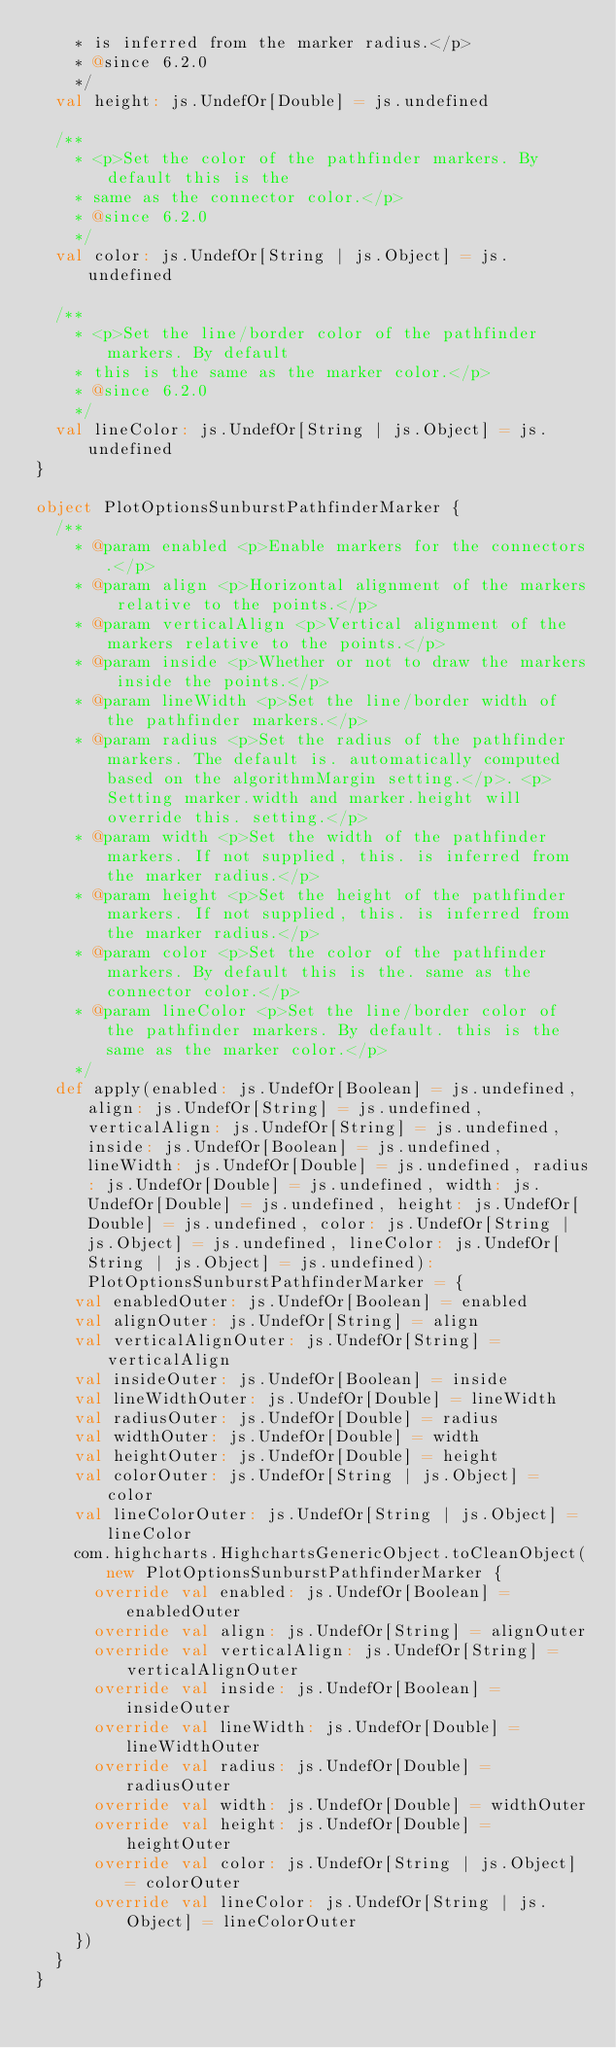Convert code to text. <code><loc_0><loc_0><loc_500><loc_500><_Scala_>    * is inferred from the marker radius.</p>
    * @since 6.2.0
    */
  val height: js.UndefOr[Double] = js.undefined

  /**
    * <p>Set the color of the pathfinder markers. By default this is the
    * same as the connector color.</p>
    * @since 6.2.0
    */
  val color: js.UndefOr[String | js.Object] = js.undefined

  /**
    * <p>Set the line/border color of the pathfinder markers. By default
    * this is the same as the marker color.</p>
    * @since 6.2.0
    */
  val lineColor: js.UndefOr[String | js.Object] = js.undefined
}

object PlotOptionsSunburstPathfinderMarker {
  /**
    * @param enabled <p>Enable markers for the connectors.</p>
    * @param align <p>Horizontal alignment of the markers relative to the points.</p>
    * @param verticalAlign <p>Vertical alignment of the markers relative to the points.</p>
    * @param inside <p>Whether or not to draw the markers inside the points.</p>
    * @param lineWidth <p>Set the line/border width of the pathfinder markers.</p>
    * @param radius <p>Set the radius of the pathfinder markers. The default is. automatically computed based on the algorithmMargin setting.</p>. <p>Setting marker.width and marker.height will override this. setting.</p>
    * @param width <p>Set the width of the pathfinder markers. If not supplied, this. is inferred from the marker radius.</p>
    * @param height <p>Set the height of the pathfinder markers. If not supplied, this. is inferred from the marker radius.</p>
    * @param color <p>Set the color of the pathfinder markers. By default this is the. same as the connector color.</p>
    * @param lineColor <p>Set the line/border color of the pathfinder markers. By default. this is the same as the marker color.</p>
    */
  def apply(enabled: js.UndefOr[Boolean] = js.undefined, align: js.UndefOr[String] = js.undefined, verticalAlign: js.UndefOr[String] = js.undefined, inside: js.UndefOr[Boolean] = js.undefined, lineWidth: js.UndefOr[Double] = js.undefined, radius: js.UndefOr[Double] = js.undefined, width: js.UndefOr[Double] = js.undefined, height: js.UndefOr[Double] = js.undefined, color: js.UndefOr[String | js.Object] = js.undefined, lineColor: js.UndefOr[String | js.Object] = js.undefined): PlotOptionsSunburstPathfinderMarker = {
    val enabledOuter: js.UndefOr[Boolean] = enabled
    val alignOuter: js.UndefOr[String] = align
    val verticalAlignOuter: js.UndefOr[String] = verticalAlign
    val insideOuter: js.UndefOr[Boolean] = inside
    val lineWidthOuter: js.UndefOr[Double] = lineWidth
    val radiusOuter: js.UndefOr[Double] = radius
    val widthOuter: js.UndefOr[Double] = width
    val heightOuter: js.UndefOr[Double] = height
    val colorOuter: js.UndefOr[String | js.Object] = color
    val lineColorOuter: js.UndefOr[String | js.Object] = lineColor
    com.highcharts.HighchartsGenericObject.toCleanObject(new PlotOptionsSunburstPathfinderMarker {
      override val enabled: js.UndefOr[Boolean] = enabledOuter
      override val align: js.UndefOr[String] = alignOuter
      override val verticalAlign: js.UndefOr[String] = verticalAlignOuter
      override val inside: js.UndefOr[Boolean] = insideOuter
      override val lineWidth: js.UndefOr[Double] = lineWidthOuter
      override val radius: js.UndefOr[Double] = radiusOuter
      override val width: js.UndefOr[Double] = widthOuter
      override val height: js.UndefOr[Double] = heightOuter
      override val color: js.UndefOr[String | js.Object] = colorOuter
      override val lineColor: js.UndefOr[String | js.Object] = lineColorOuter
    })
  }
}
</code> 